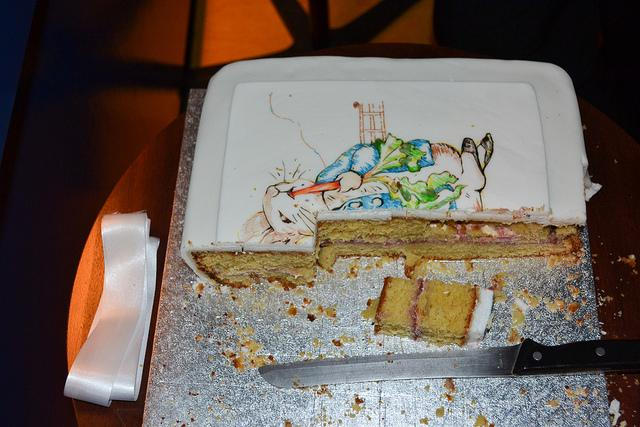Which age range may this cake have been for? Please explain your reasoning. child. It had the picture of a cartoon character on it. 